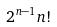<formula> <loc_0><loc_0><loc_500><loc_500>2 ^ { n - 1 } n !</formula> 